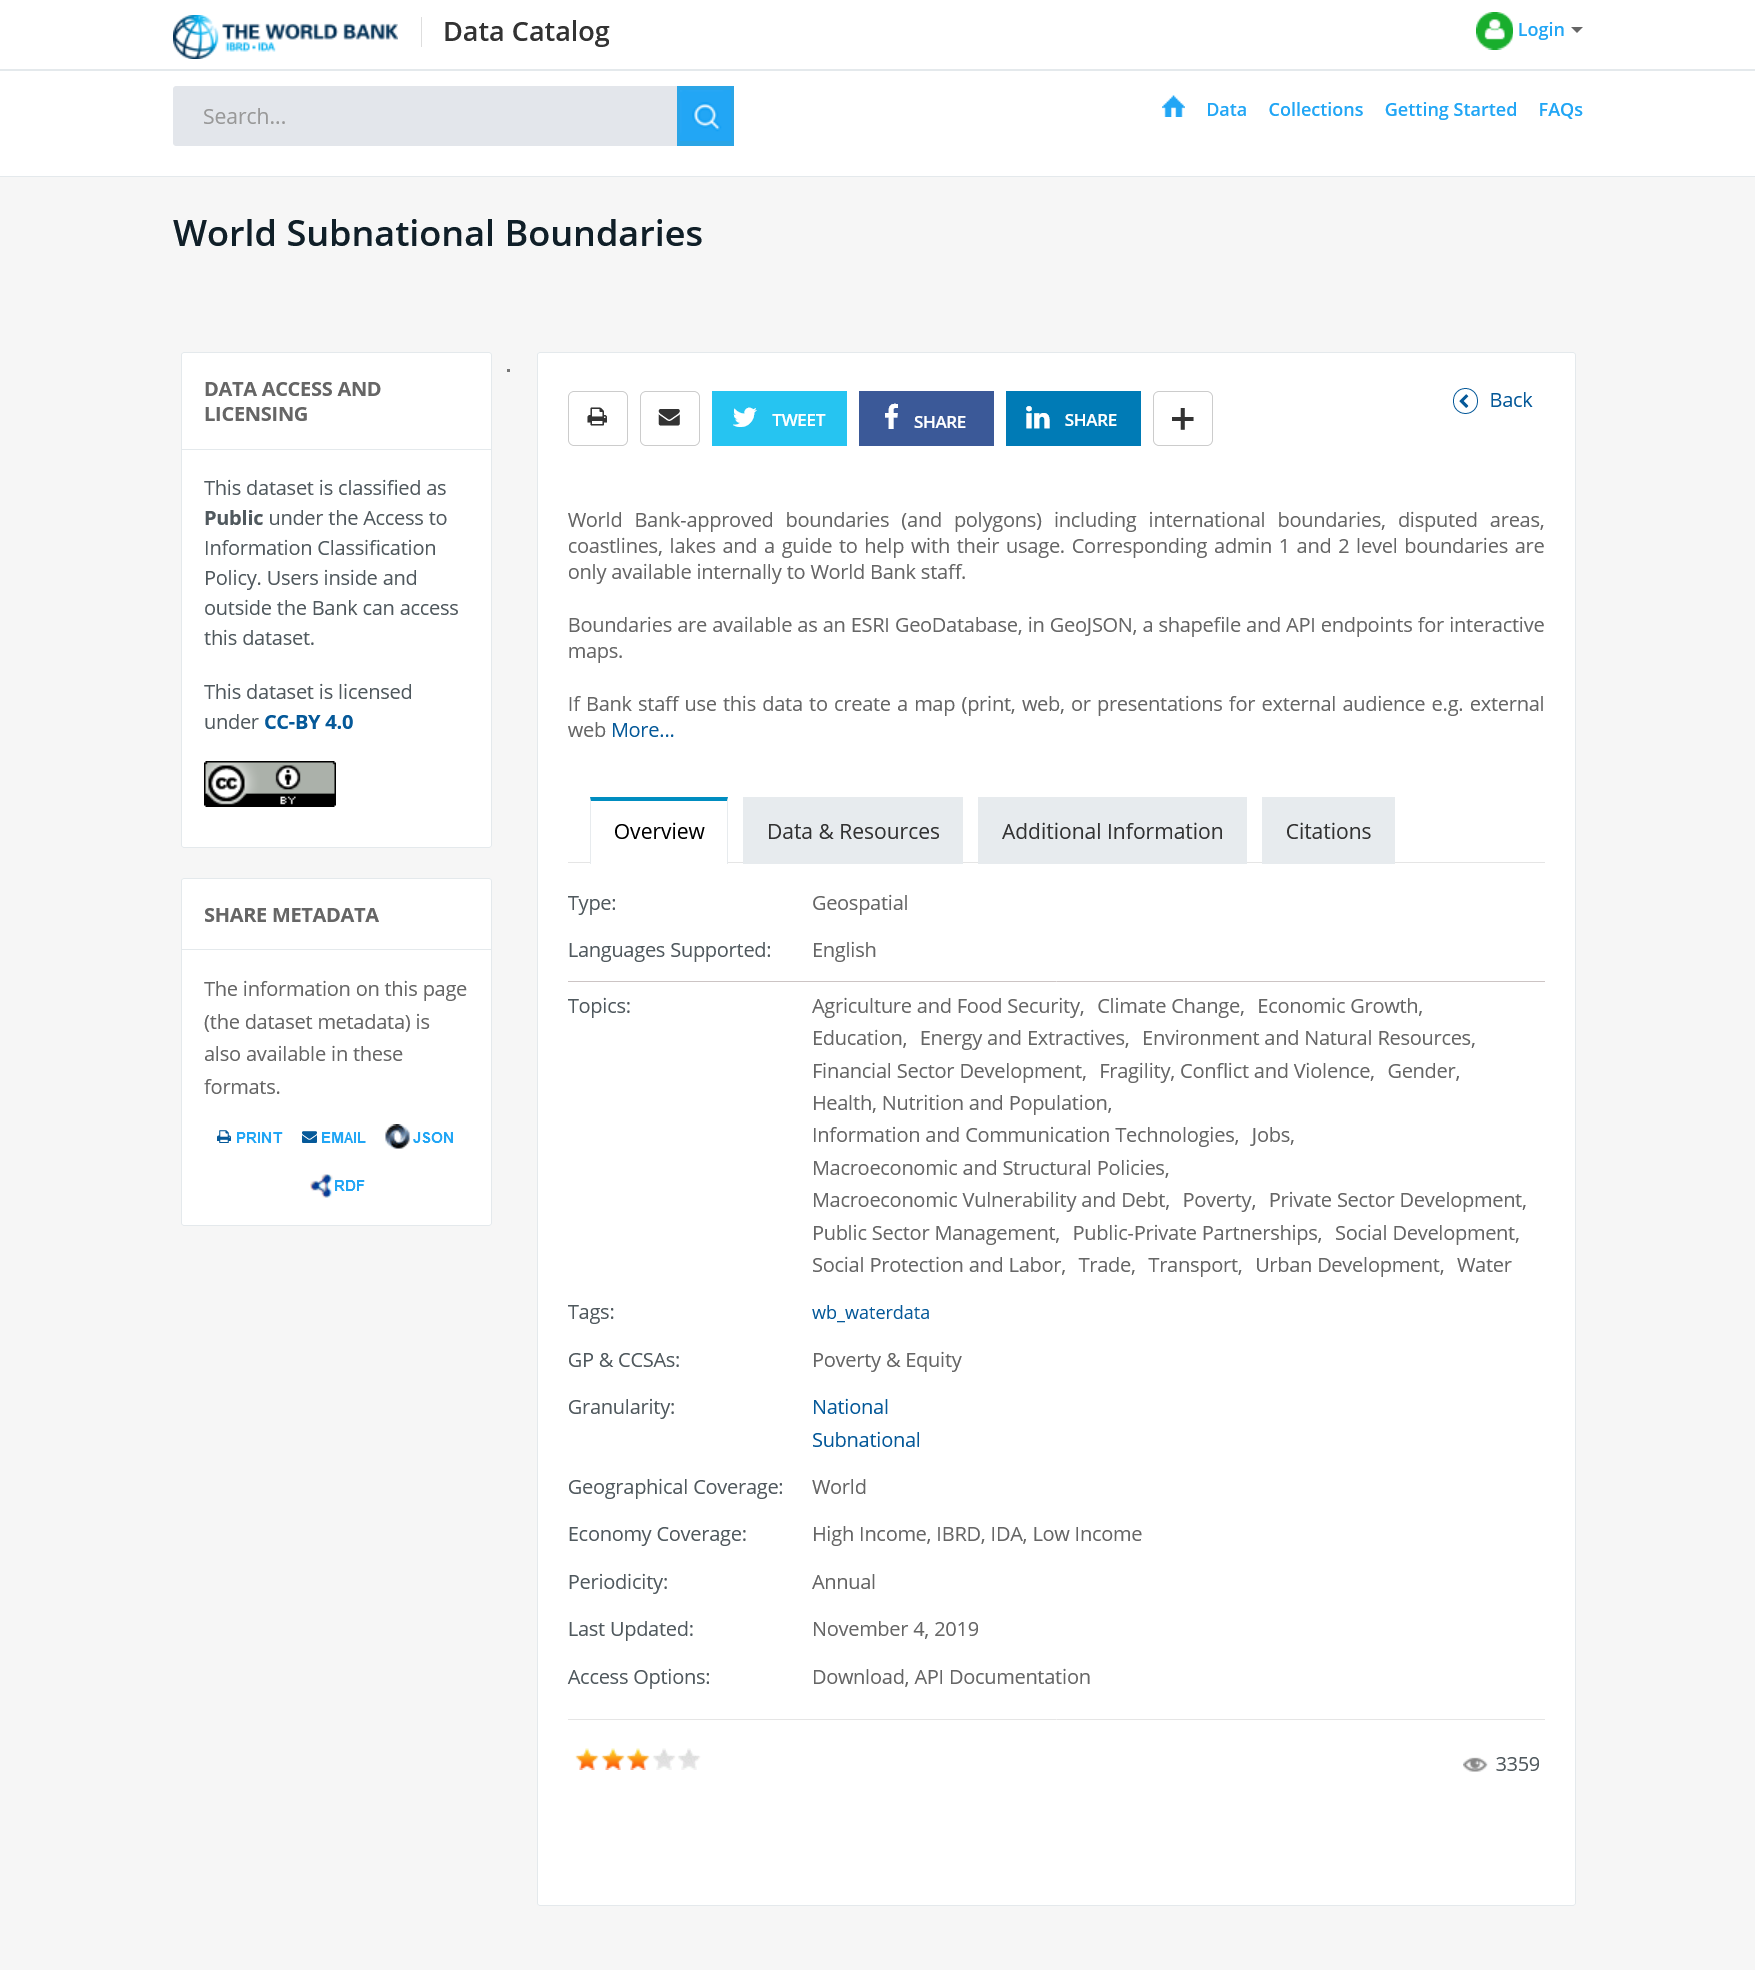Mention a couple of crucial points in this snapshot. It is possible to print this article. It is not possible for the general public to access the boundaries of administrative regions at the level of administration 1 and 2. The dataset is publicly available. 